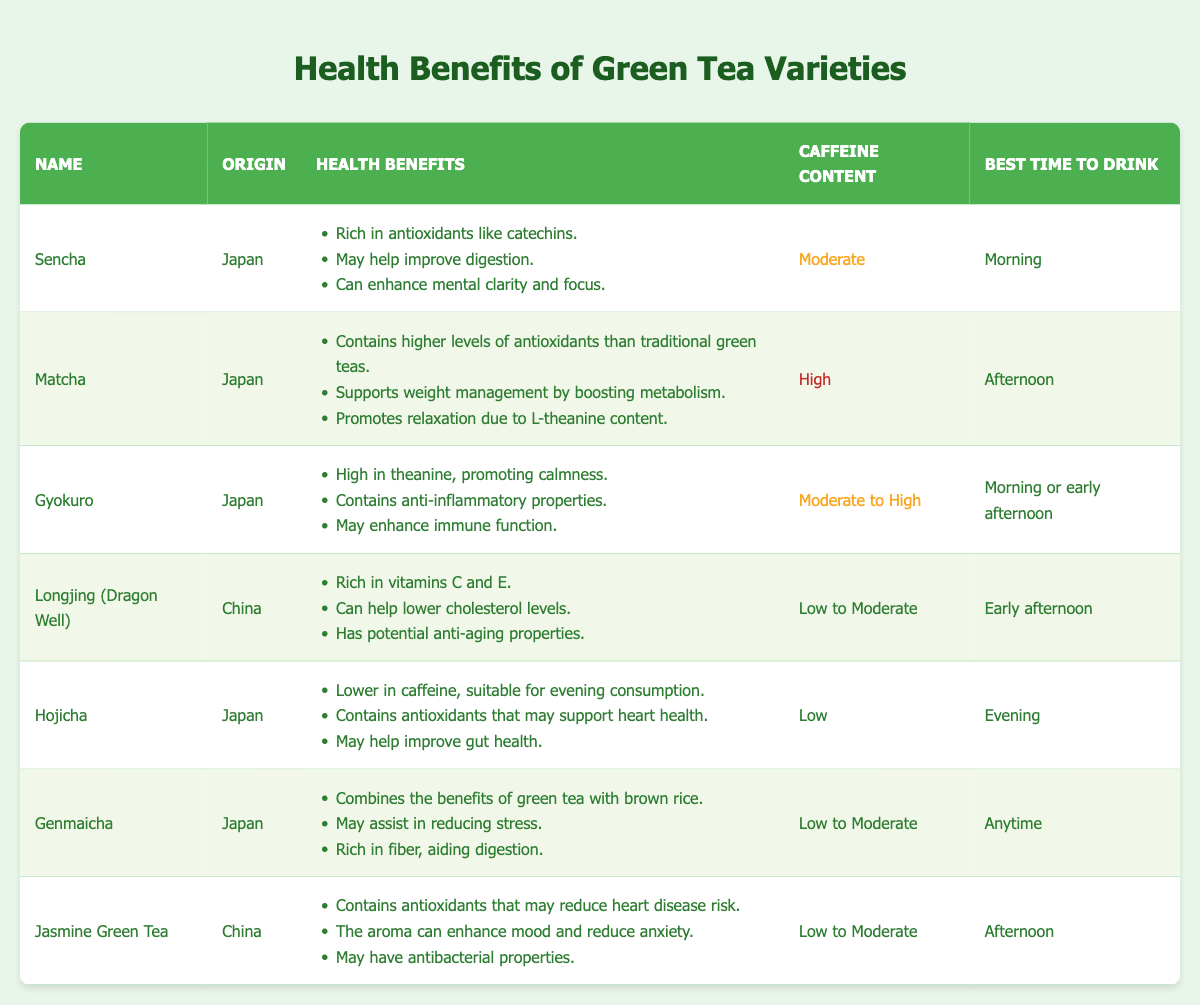What are the health benefits of Matcha? Matcha's health benefits listed in the table include: higher levels of antioxidants than traditional green teas, supporting weight management by boosting metabolism, and promoting relaxation due to L-theanine content.
Answer: Contains higher levels of antioxidants, supports weight management, promotes relaxation Which green tea variety is suitable for evening consumption? The only variety listed as low in caffeine, suitable for evening consumption, is Hojicha. The table mentions its lower caffeine content and its recommended drinking time.
Answer: Hojicha Is Genmaicha higher in caffeine content than Longjing (Dragon Well)? Genmaicha has a caffeine content of low to moderate while Longjing (Dragon Well) has a caffeine content categorized as low to moderate. Since both have overlapping categories, it's not correct to say one is higher than the other.
Answer: No What is the best time to drink Gyokuro? According to the table, Gyokuro is suggested to be drunk in the morning or early afternoon. The best time to drink each variety is clearly listed in the respective rows.
Answer: Morning or early afternoon How many varieties of green tea listed have high caffeine content? The table shows that there are two varieties categorized as having high caffeine content: Matcha and Gyokuro (which is moderate to high). By counting them, we can conclude the total.
Answer: 2 Does Jasmine Green Tea have antibacterial properties? Yes, according to the table, one of the health benefits of Jasmine Green Tea is that it may have antibacterial properties, as stated explicitly.
Answer: Yes Which green tea variety has the highest caffeine content? Looking at the caffeine content column, Matcha is listed as high caffeine, whereas Gyokuro is listed as moderate to high. Therefore, based on the table, Matcha would be considered as having the highest caffeine content.
Answer: Matcha What are the health benefits of Hojicha and Genmaicha combined? Hojicha is noted for heart health support and improved gut health. Genmaicha provides stress reduction and aids digestion. Combining these benefits, one could emphasize the overall health support for gut and heart health.
Answer: Heart health, gut health, stress reduction, improved digestion Which tea is rich in vitamins C and E? Longjing (Dragon Well) is specified in the table as being rich in vitamins C and E, making it notable for its vitamin content.
Answer: Longjing (Dragon Well) 